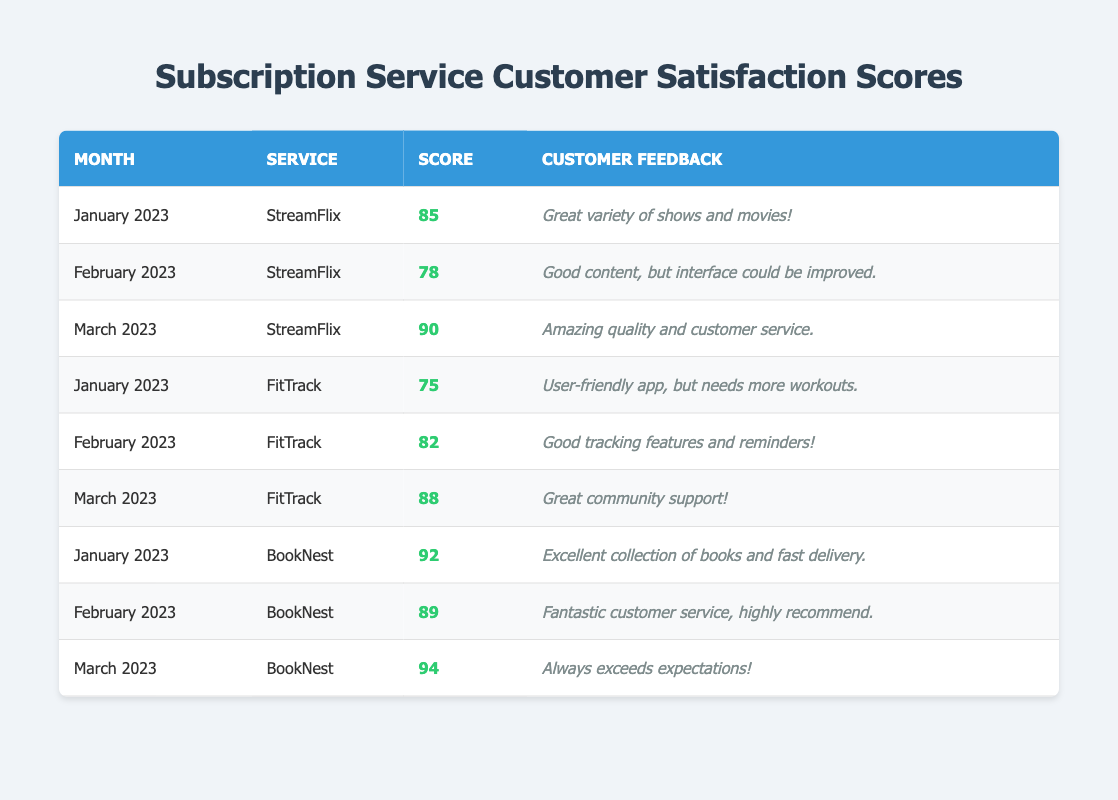What was the customer satisfaction score for StreamFlix in March 2023? The table data shows that the score for StreamFlix in March 2023 was 90 as listed in the respective row of the table.
Answer: 90 Which service had the highest customer satisfaction score in January 2023? By comparing the scores for January 2023, StreamFlix scored 85, FitTrack scored 75, and BookNest scored 92. BookNest had the highest score of 92.
Answer: BookNest What is the average customer satisfaction score for FitTrack over the three months? The scores for FitTrack over the three months are 75, 82, and 88. The sum of these scores is 75 + 82 + 88 = 245. Dividing by the number of months (3), the average score is 245 / 3 = 81.67.
Answer: 81.67 Did any service receive a score of 90 or above in February 2023? The scores for February 2023 are 78 for StreamFlix, 82 for FitTrack, and 89 for BookNest. None of these scores meet or exceed 90, therefore the answer is no.
Answer: No Which month did BookNest receive the highest satisfaction score, and what was that score? By examining the scores for BookNest, January 2023 had a score of 92, February 2023 was 89, and March 2023 was 94. March 2023 had the highest score of 94.
Answer: March 2023, 94 What was the difference in customer satisfaction scores between FitTrack and StreamFlix in February 2023? In February 2023, FitTrack scored 82 and StreamFlix scored 78. The difference is 82 - 78 = 4.
Answer: 4 Was customer feedback for BookNest generally positive across the three months? The feedback for BookNest was “Excellent collection of books and fast delivery,” “Fantastic customer service, highly recommend,” and “Always exceeds expectations!” All these comments are positive, so the answer is yes.
Answer: Yes What service had the lowest satisfaction score in the dataset? The lowest score in the dataset is 75 for FitTrack in January 2023, as per the scores listed in the table.
Answer: FitTrack What was the trend of the customer satisfaction scores for StreamFlix over the three months? The scores were 85 in January, 78 in February, and then increased to 90 in March. This indicates a downward trend from January to February and then a rise in March.
Answer: Initial decrease, then increase 